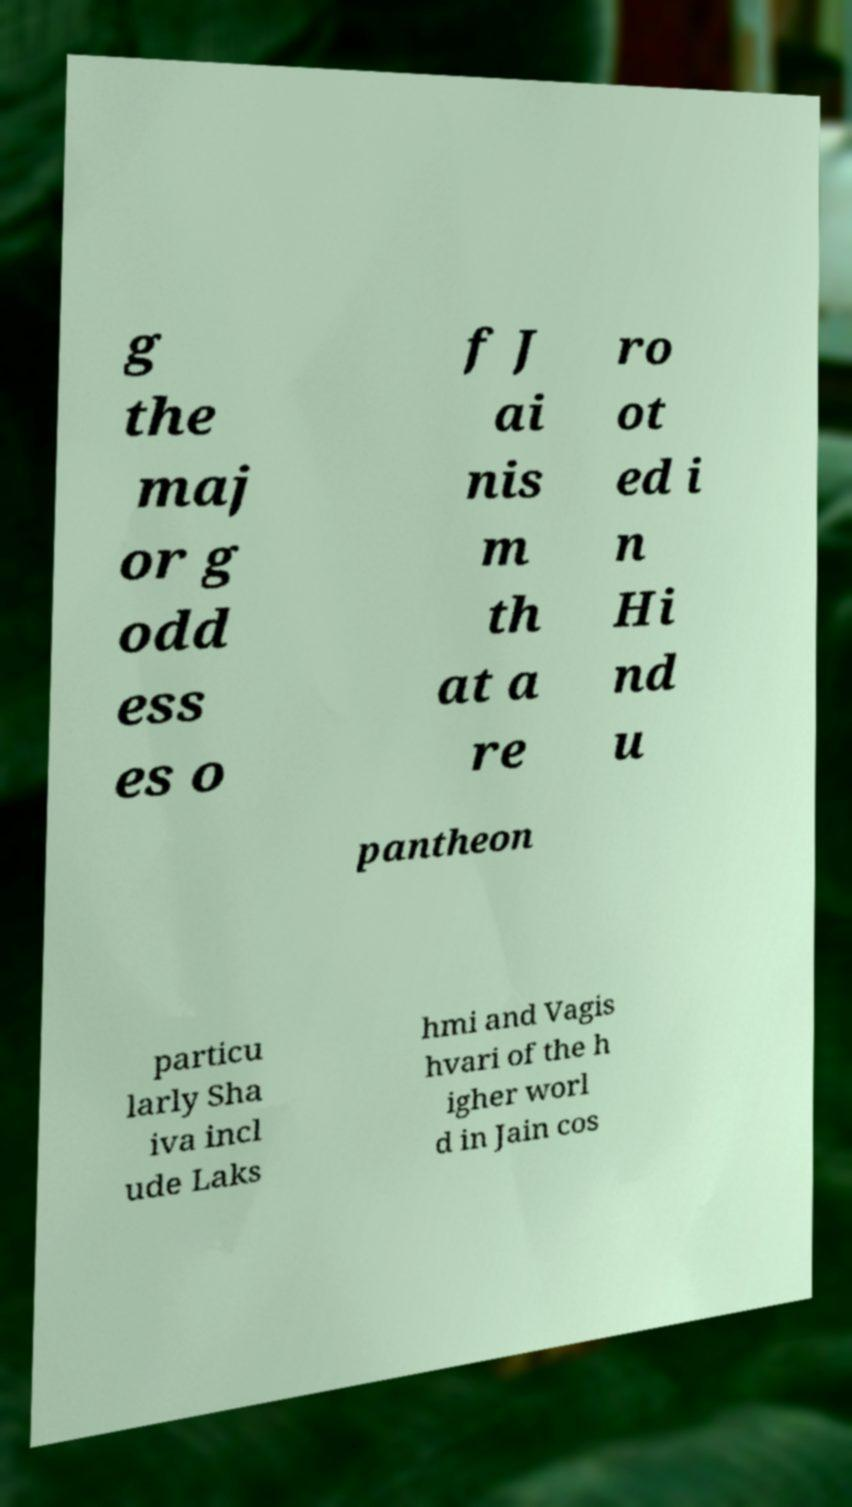There's text embedded in this image that I need extracted. Can you transcribe it verbatim? g the maj or g odd ess es o f J ai nis m th at a re ro ot ed i n Hi nd u pantheon particu larly Sha iva incl ude Laks hmi and Vagis hvari of the h igher worl d in Jain cos 